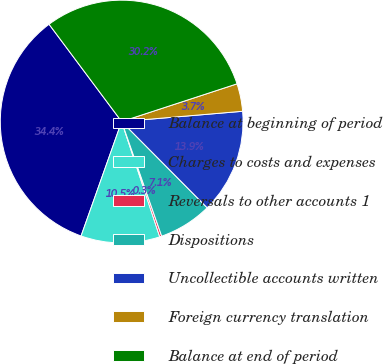Convert chart to OTSL. <chart><loc_0><loc_0><loc_500><loc_500><pie_chart><fcel>Balance at beginning of period<fcel>Charges to costs and expenses<fcel>Reversals to other accounts 1<fcel>Dispositions<fcel>Uncollectible accounts written<fcel>Foreign currency translation<fcel>Balance at end of period<nl><fcel>34.37%<fcel>10.5%<fcel>0.27%<fcel>7.09%<fcel>13.91%<fcel>3.68%<fcel>30.17%<nl></chart> 